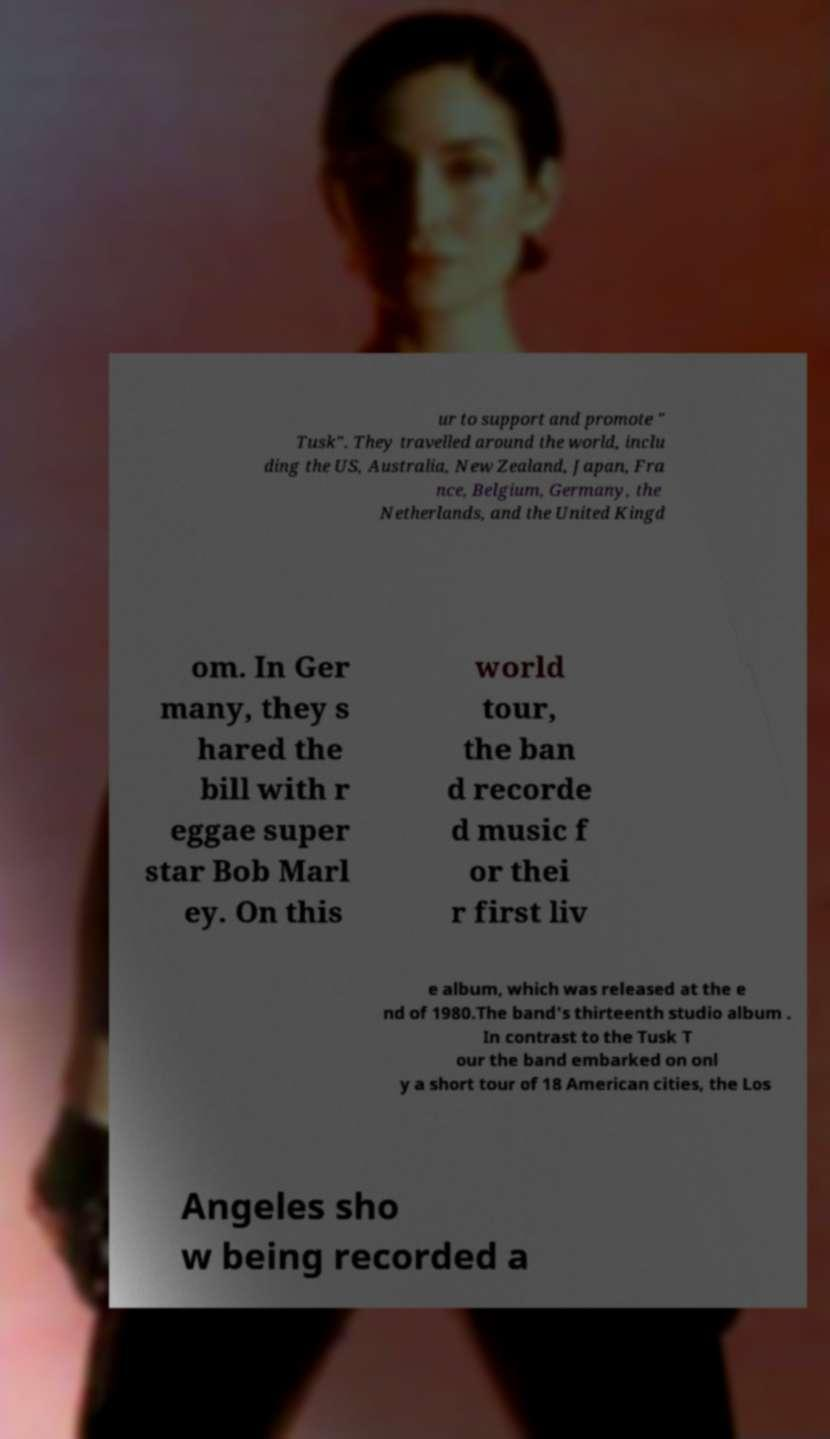Can you accurately transcribe the text from the provided image for me? ur to support and promote " Tusk". They travelled around the world, inclu ding the US, Australia, New Zealand, Japan, Fra nce, Belgium, Germany, the Netherlands, and the United Kingd om. In Ger many, they s hared the bill with r eggae super star Bob Marl ey. On this world tour, the ban d recorde d music f or thei r first liv e album, which was released at the e nd of 1980.The band's thirteenth studio album . In contrast to the Tusk T our the band embarked on onl y a short tour of 18 American cities, the Los Angeles sho w being recorded a 